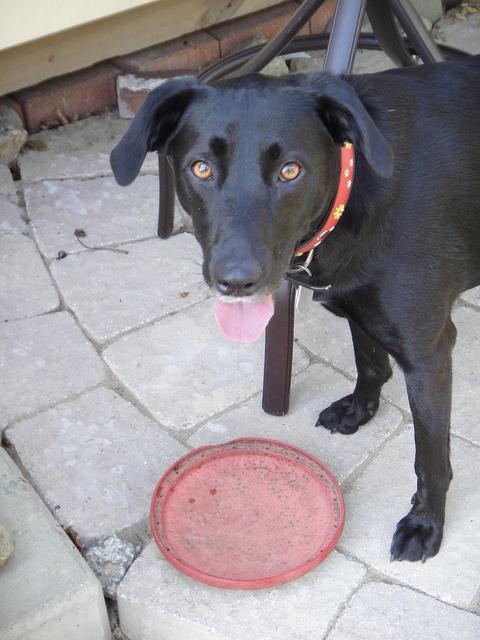How many people are shown?
Give a very brief answer. 0. 